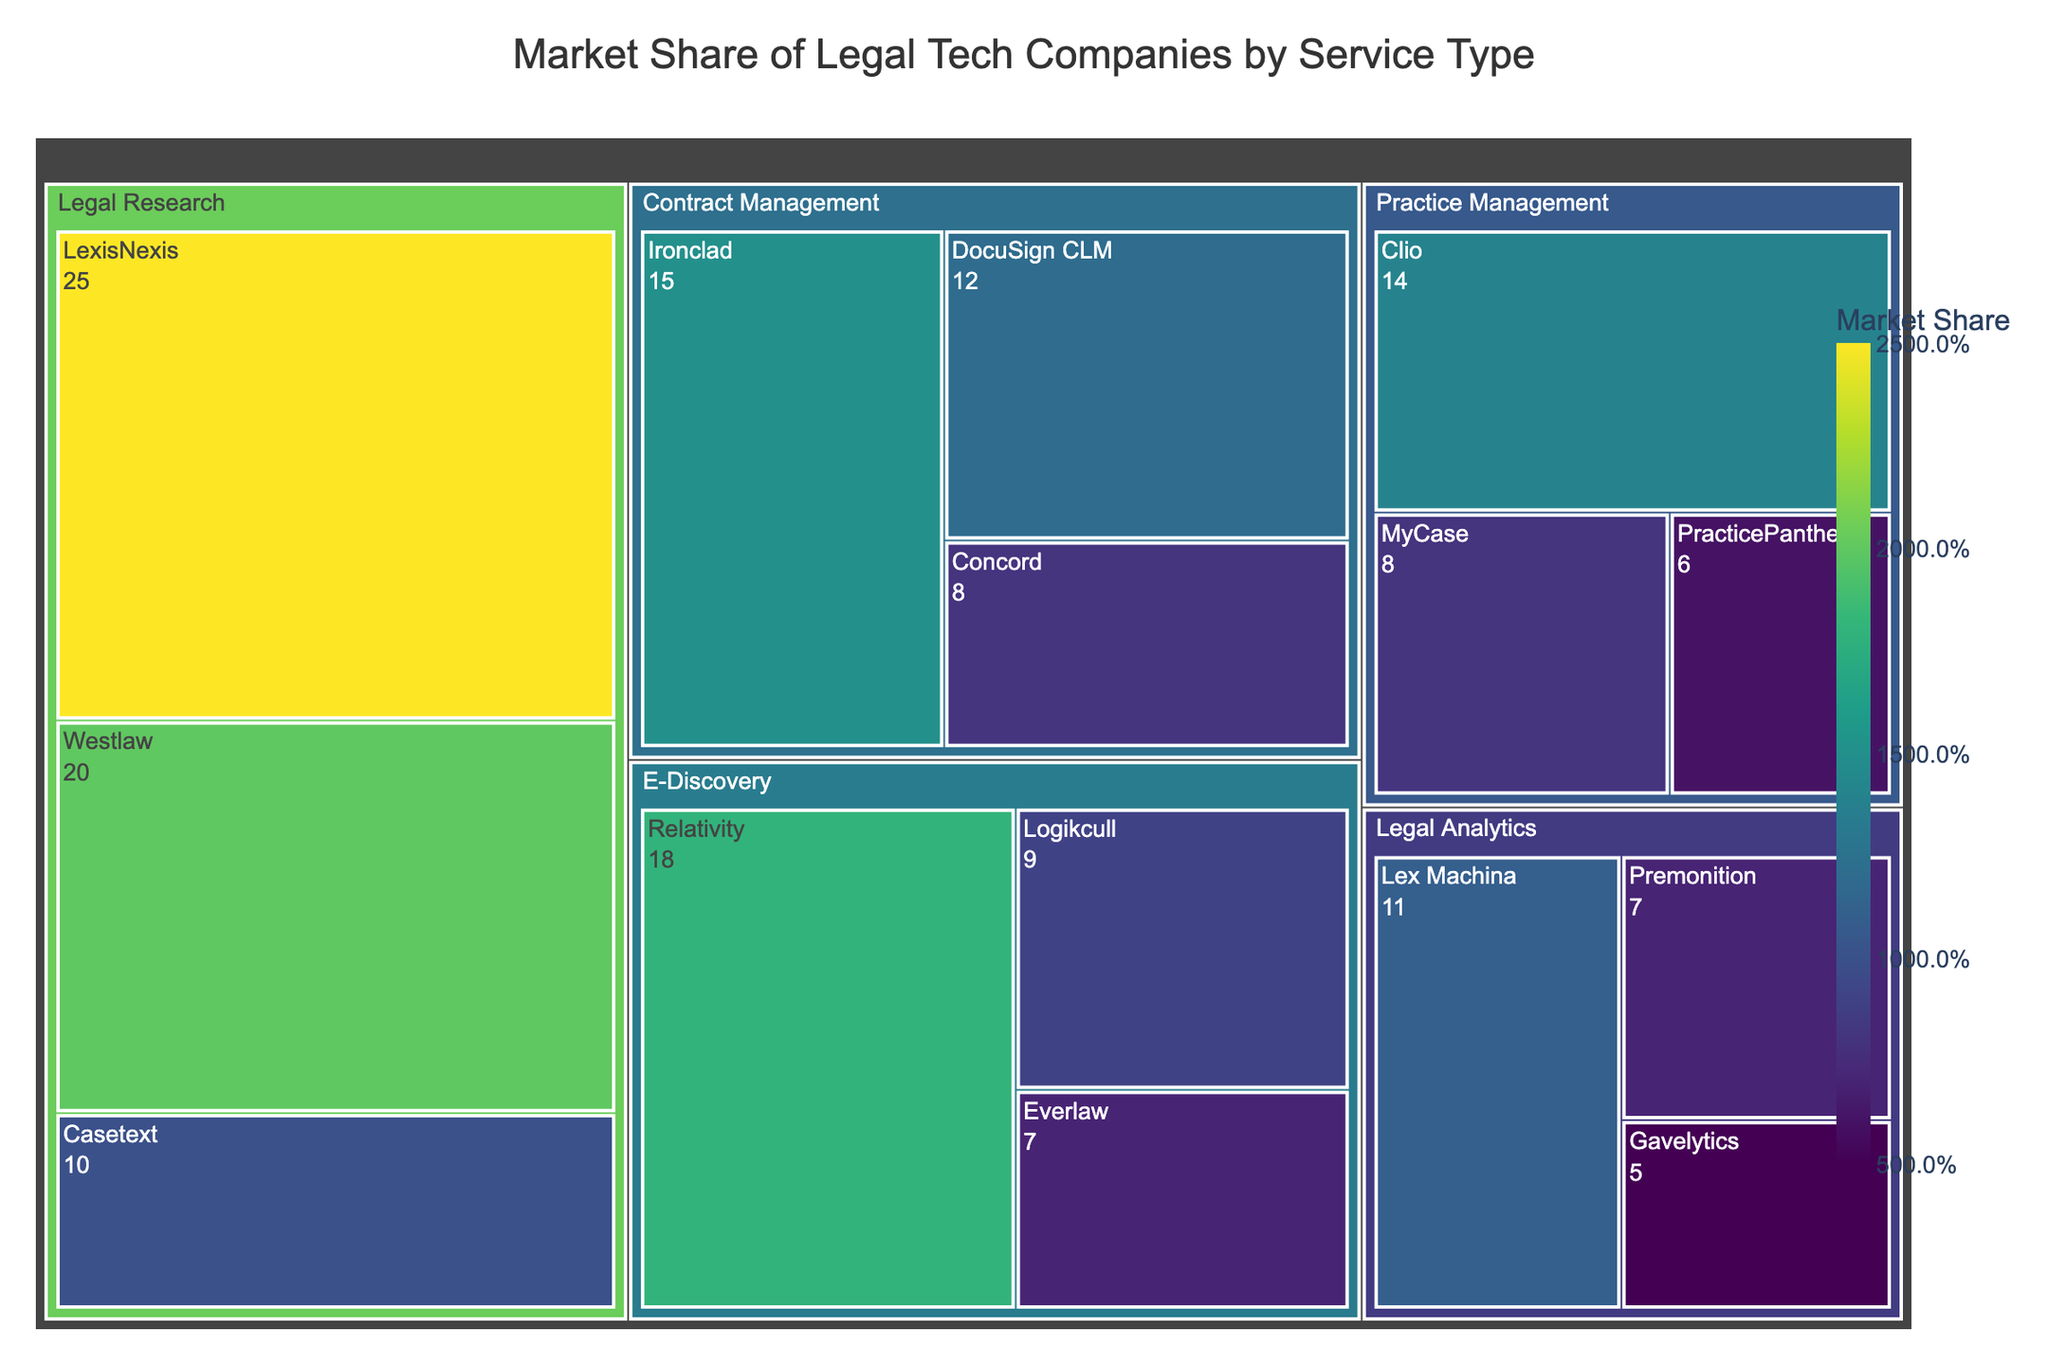What is the market share of LexisNexis in Legal Research? The figure shows a treemap, where each subcategory is represented by a tile. Looking at the Legal Research category, the LexisNexis tile shows a market share value.
Answer: 25% What is the title of the treemap? The title is displayed at the top of the treemap.
Answer: Market Share of Legal Tech Companies by Service Type Which legal tech company has the highest market share in the Contract Management category? In the Contract Management category, each subcategory is compared by the size of their tiles. The largest tile represents the company with the highest market share.
Answer: Ironclad What is the total market share of the E-Discovery category? Summing up the market shares of all subcategories under the E-Discovery category: 18 (Relativity) + 9 (Logikcull) + 7 (Everlaw) = 34.
Answer: 34% Which category has the most companies listed? The number of tiles representing subcategories under each category tells the answer.
Answer: Legal Analytics What is the color representing the highest market share? The color representing the highest market share would be the one with the maximum value in the color scale.
Answer: Darkest (near purple) Compare the market share of Clio and MyCase in Practice Management. By looking at the size and values of the tiles for Clio and MyCase in Practice Management: Clio has 14 and MyCase has 8. Clio's market share is greater.
Answer: Clio has a higher market share What's the combined market share of LexisNexis and Westlaw in Legal Research? Summing up the market shares of LexisNexis (25) and Westlaw (20) in Legal Research: 25 + 20 = 45.
Answer: 45% Which company has the smallest market share in Legal Analytics? By comparing the tiles in the Legal Analytics category, the smallest tile denotes the company with the smallest market share.
Answer: Gavelytics Is the market share of Ironclad higher than the total market share of E-Discovery companies? Comparing the value of Ironclad (15) with the total of E-Discovery (34), Ironclad's market share is less.
Answer: No 